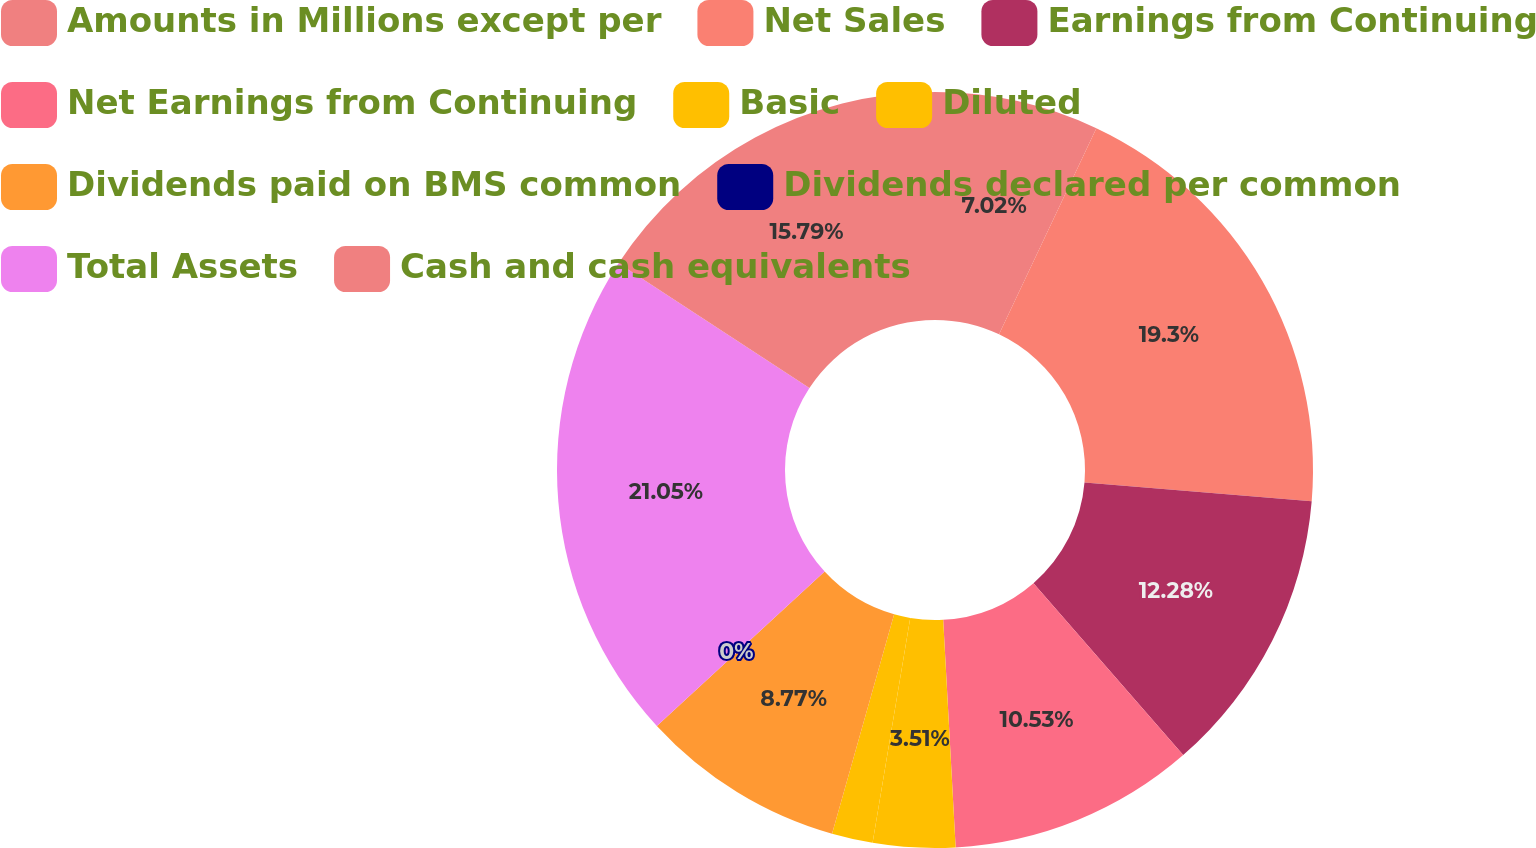<chart> <loc_0><loc_0><loc_500><loc_500><pie_chart><fcel>Amounts in Millions except per<fcel>Net Sales<fcel>Earnings from Continuing<fcel>Net Earnings from Continuing<fcel>Basic<fcel>Diluted<fcel>Dividends paid on BMS common<fcel>Dividends declared per common<fcel>Total Assets<fcel>Cash and cash equivalents<nl><fcel>7.02%<fcel>19.3%<fcel>12.28%<fcel>10.53%<fcel>3.51%<fcel>1.75%<fcel>8.77%<fcel>0.0%<fcel>21.05%<fcel>15.79%<nl></chart> 